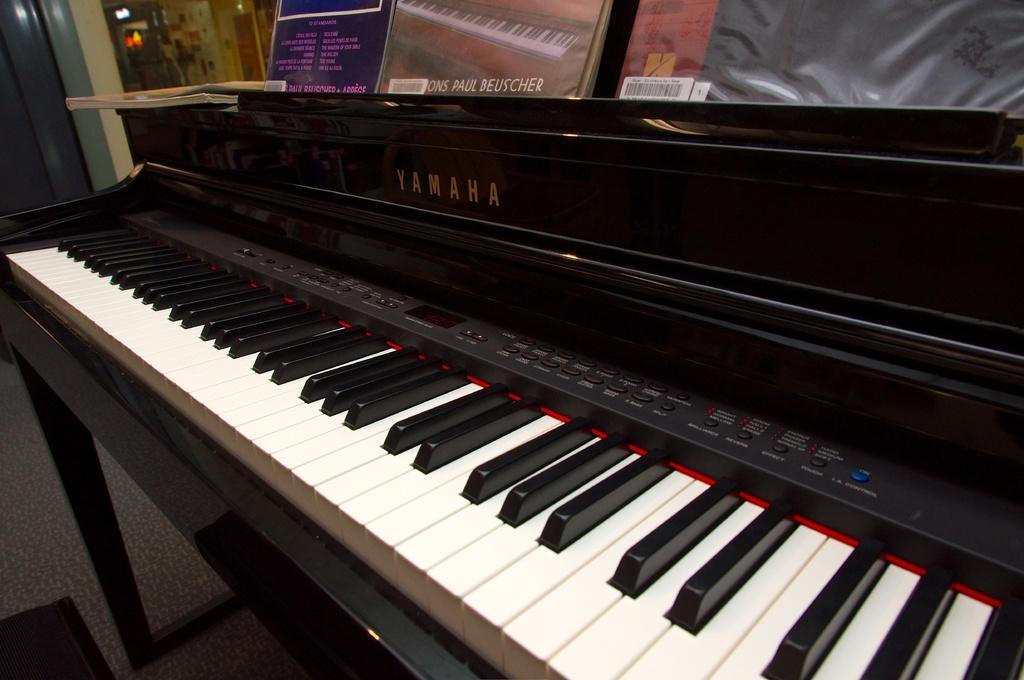Please provide a concise description of this image. In this image there is a piano with a keyboard, there are some small buttons on the keyboard. There is a text on it. Some of the books were placed on top of the piano. 